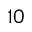Convert formula to latex. <formula><loc_0><loc_0><loc_500><loc_500>1 0</formula> 